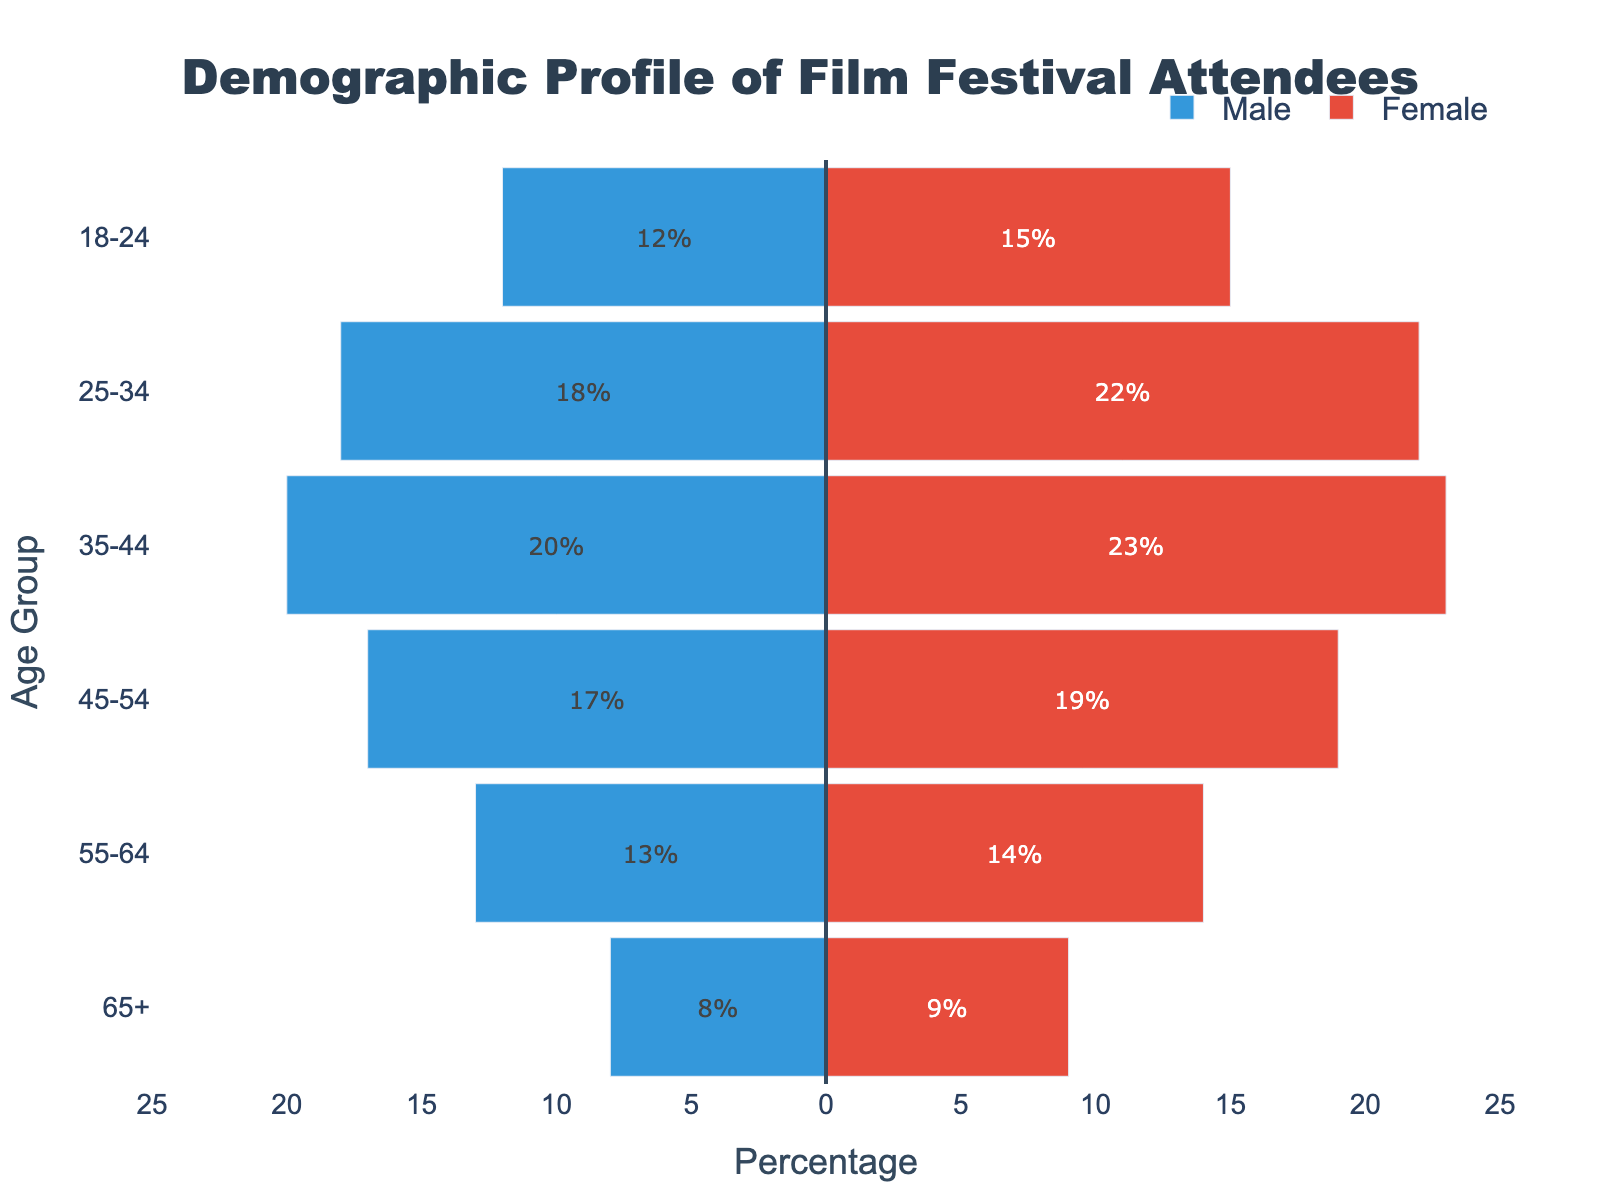What are the age groups represented in the population pyramid? The y-axis of the population pyramid lists the age groups. These are "18-24", "25-34", "35-44", "45-54", "55-64", and "65+".
Answer: 18-24, 25-34, 35-44, 45-54, 55-64, 65+ What is the title of the chart? The title of the chart is displayed at the top. It reads "Demographic Profile of Film Festival Attendees".
Answer: Demographic Profile of Film Festival Attendees Which color represents male attendees? The color of the bars for male attendees is blue. This can be inferred from the legend which assigns the color blue to "Male".
Answer: Blue Which age group has the highest number of female attendees? By comparing the bars that represent female attendees, the age group 35-44 has the highest number, shown by the longest red bar.
Answer: 35-44 How many male attendees are there in the 25-34 age group? The population pyramid shows that the male bar for the age group 25-34 extends to -18%, indicating 18 male attendees.
Answer: 18 What is the total number of attendees aged 45-54? Adding the number of male and female attendees in the age group 45-54, we get 17 males + 19 females = 36 attendees.
Answer: 36 What is the difference in the number of attendees between males and females aged 55-64? The number of female attendees aged 55-64 is 14, and the number of male attendees is 13. The difference is 14 - 13 = 1.
Answer: 1 Which age group has the smallest male demographic? The age group "65+" has the smallest number of male attendees, with the male bar only extending to -8%.
Answer: 65+ Across all age groups, do male or female attendees generally have higher percentages? Examining each pair of bars across age groups, female attendees generally have higher percentages, as evidenced by longer red bars compared to blue bars.
Answer: Female attendees What percentage of total attendees are female in the 18-24 age group? The female attendees in the 18-24 age group are 15 out of a total of 27 (12 male + 15 female). So, the percentage is (15/27) * 100 = 55.56%.
Answer: 55.56% 